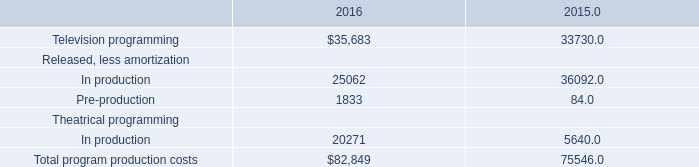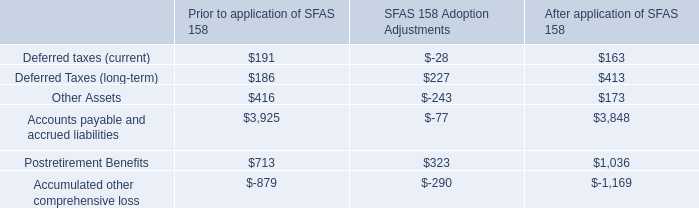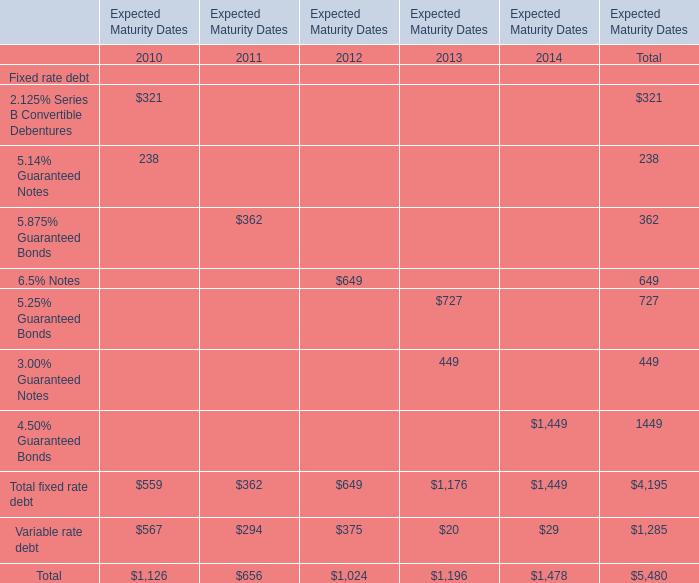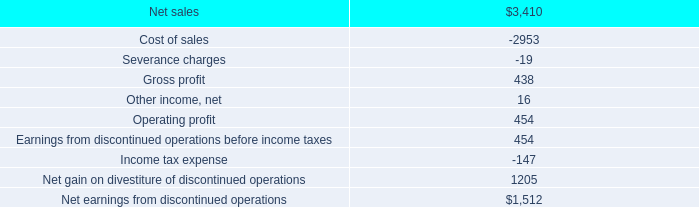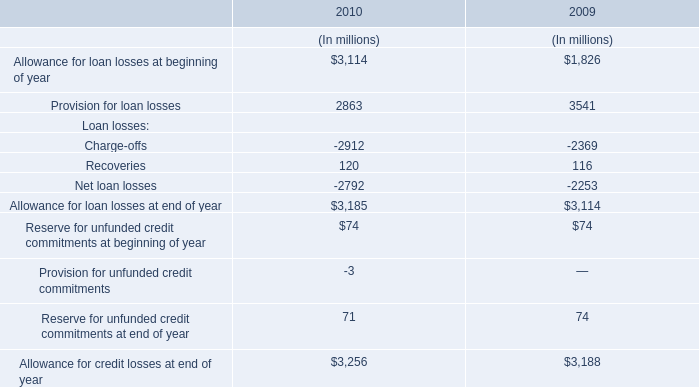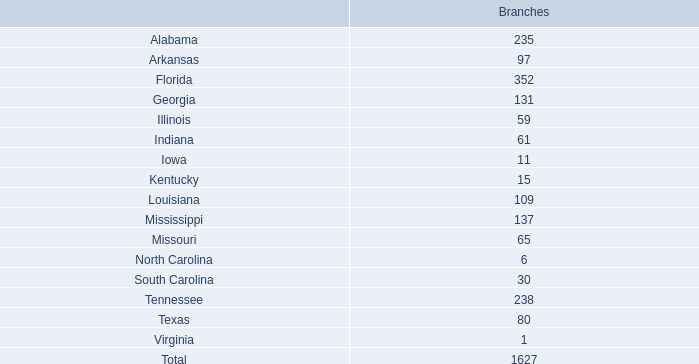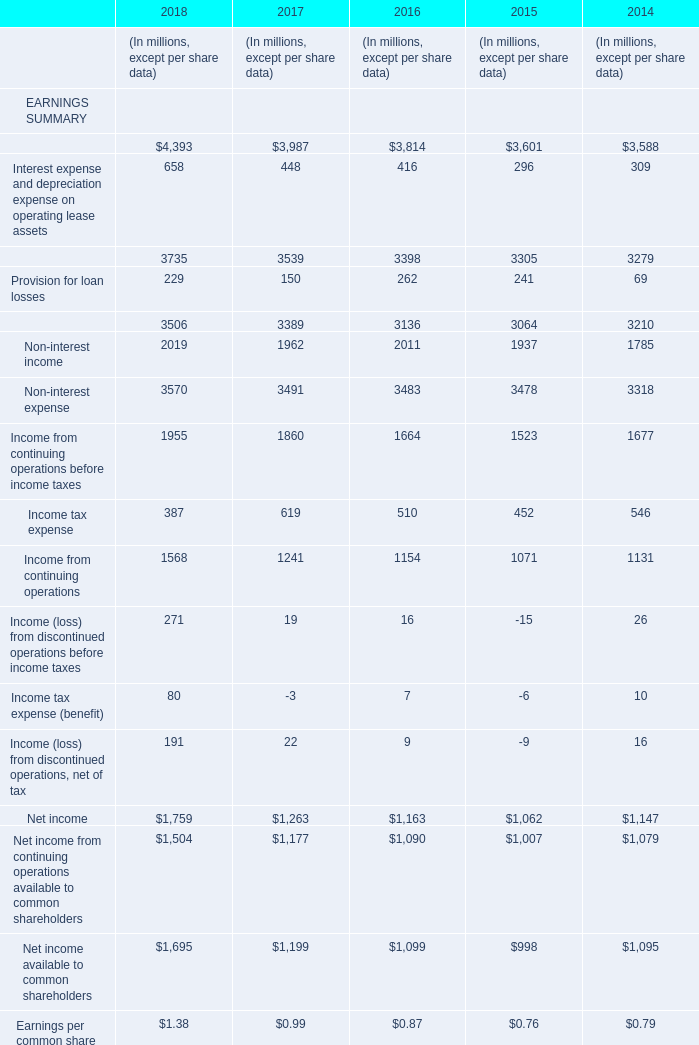What is the value of the Total fixed rate debt for the Expected Maturity Dates 2012? 
Answer: 649. 